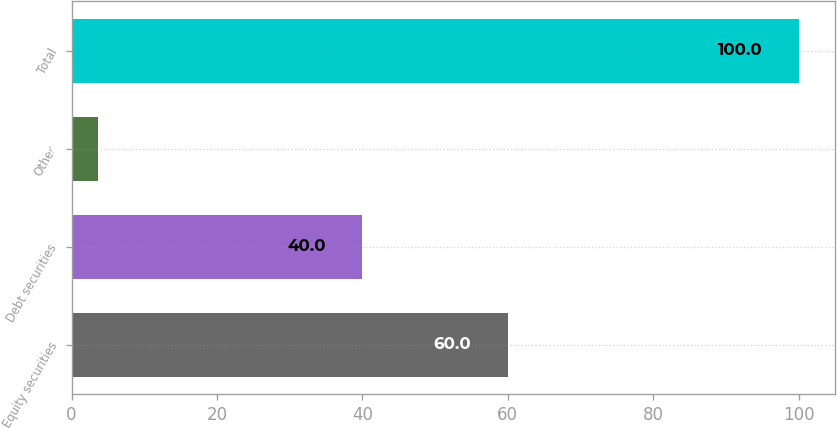<chart> <loc_0><loc_0><loc_500><loc_500><bar_chart><fcel>Equity securities<fcel>Debt securities<fcel>Other<fcel>Total<nl><fcel>60<fcel>40<fcel>3.66<fcel>100<nl></chart> 